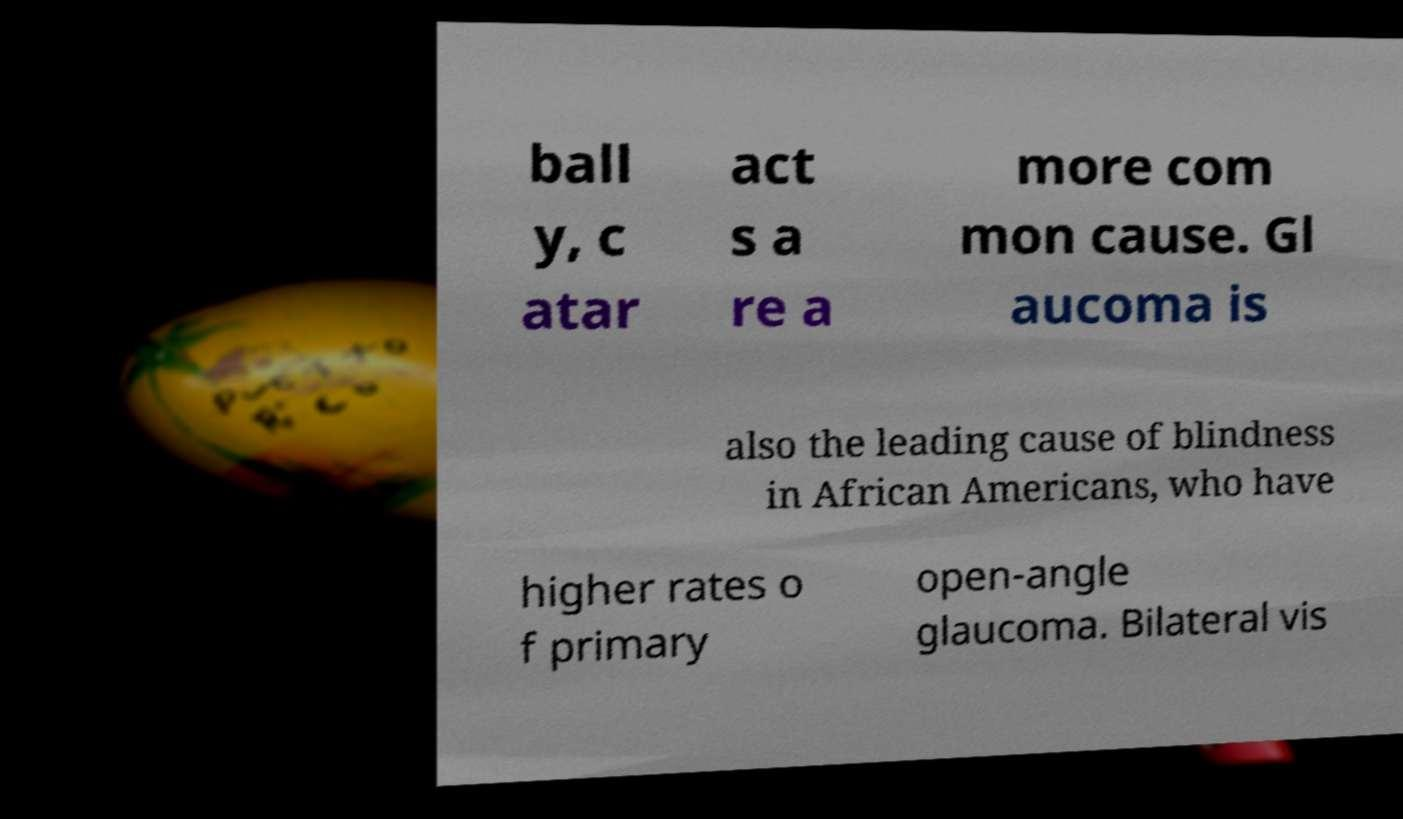There's text embedded in this image that I need extracted. Can you transcribe it verbatim? ball y, c atar act s a re a more com mon cause. Gl aucoma is also the leading cause of blindness in African Americans, who have higher rates o f primary open-angle glaucoma. Bilateral vis 